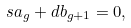Convert formula to latex. <formula><loc_0><loc_0><loc_500><loc_500>s a _ { g } + d b _ { g + 1 } = 0 ,</formula> 